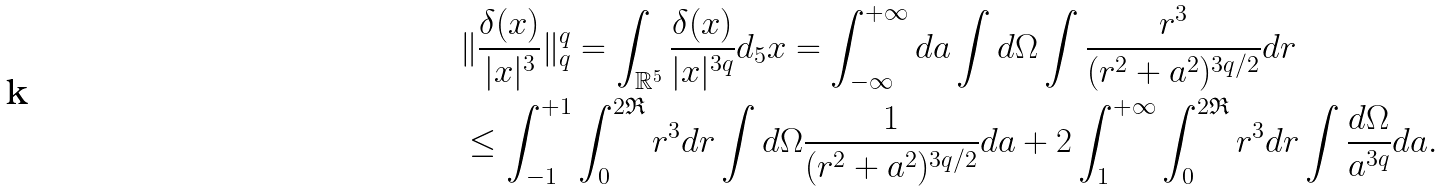Convert formula to latex. <formula><loc_0><loc_0><loc_500><loc_500>& \| \frac { \delta ( x ) } { | x | ^ { 3 } } \| _ { q } ^ { q } = \int _ { \mathbb { R } ^ { 5 } } \frac { \delta ( x ) } { | x | ^ { 3 q } } d _ { 5 } x = \int _ { - \infty } ^ { + \infty } d a \int d \Omega \int \frac { r ^ { 3 } } { ( r ^ { 2 } + a ^ { 2 } ) ^ { 3 q / 2 } } d r \\ & \leq \int _ { - 1 } ^ { + 1 } \int _ { 0 } ^ { 2 \mathfrak { R } } r ^ { 3 } d r \int d \Omega \frac { 1 } { ( r ^ { 2 } + a ^ { 2 } ) ^ { 3 q / 2 } } d a + 2 \int _ { 1 } ^ { + \infty } \int _ { 0 } ^ { 2 \mathfrak { R } } r ^ { 3 } d r \int \frac { d \Omega } { a ^ { 3 q } } d a .</formula> 